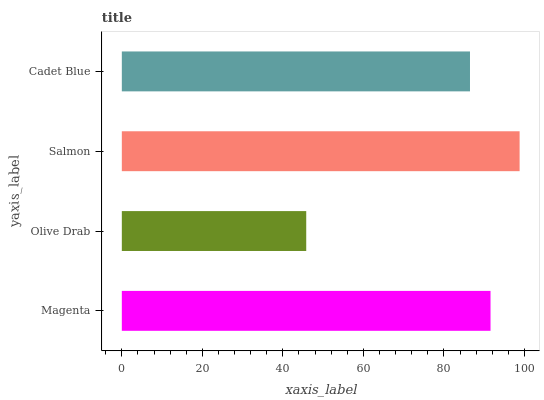Is Olive Drab the minimum?
Answer yes or no. Yes. Is Salmon the maximum?
Answer yes or no. Yes. Is Salmon the minimum?
Answer yes or no. No. Is Olive Drab the maximum?
Answer yes or no. No. Is Salmon greater than Olive Drab?
Answer yes or no. Yes. Is Olive Drab less than Salmon?
Answer yes or no. Yes. Is Olive Drab greater than Salmon?
Answer yes or no. No. Is Salmon less than Olive Drab?
Answer yes or no. No. Is Magenta the high median?
Answer yes or no. Yes. Is Cadet Blue the low median?
Answer yes or no. Yes. Is Cadet Blue the high median?
Answer yes or no. No. Is Magenta the low median?
Answer yes or no. No. 